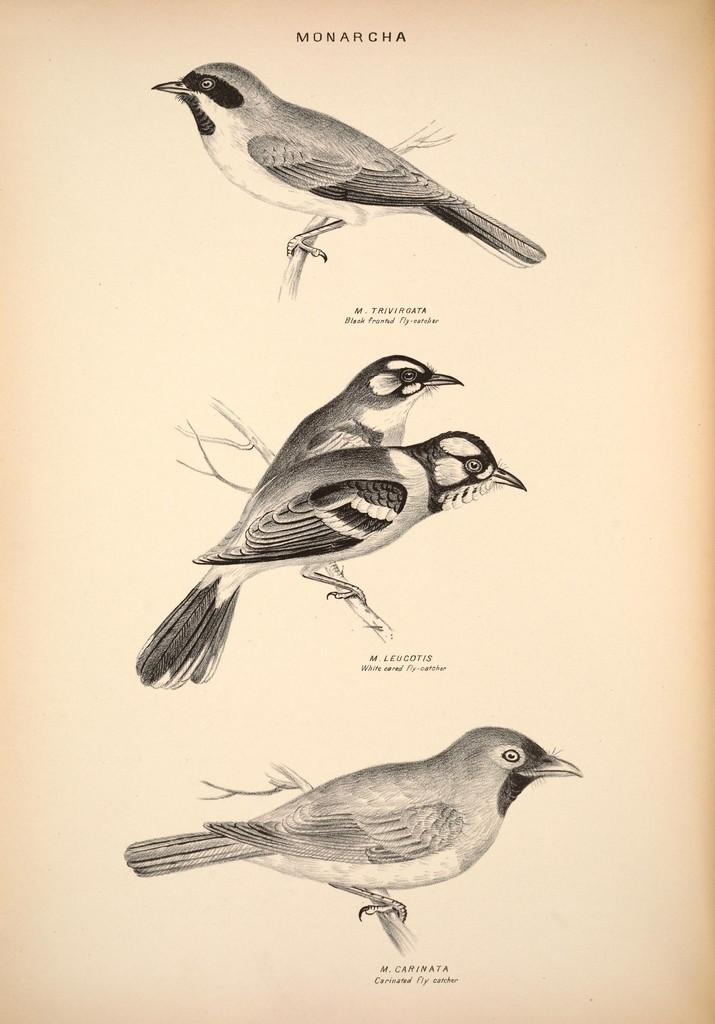What is the main subject of the paper in the image? The paper contains pictures of birds. Are there any words or text on the paper? Yes, there is text present near the pictures of birds on the paper. Where is the throne located in the image? There is no throne present in the image. What part of the brain is depicted in the image? There is no depiction of a brain in the image. 